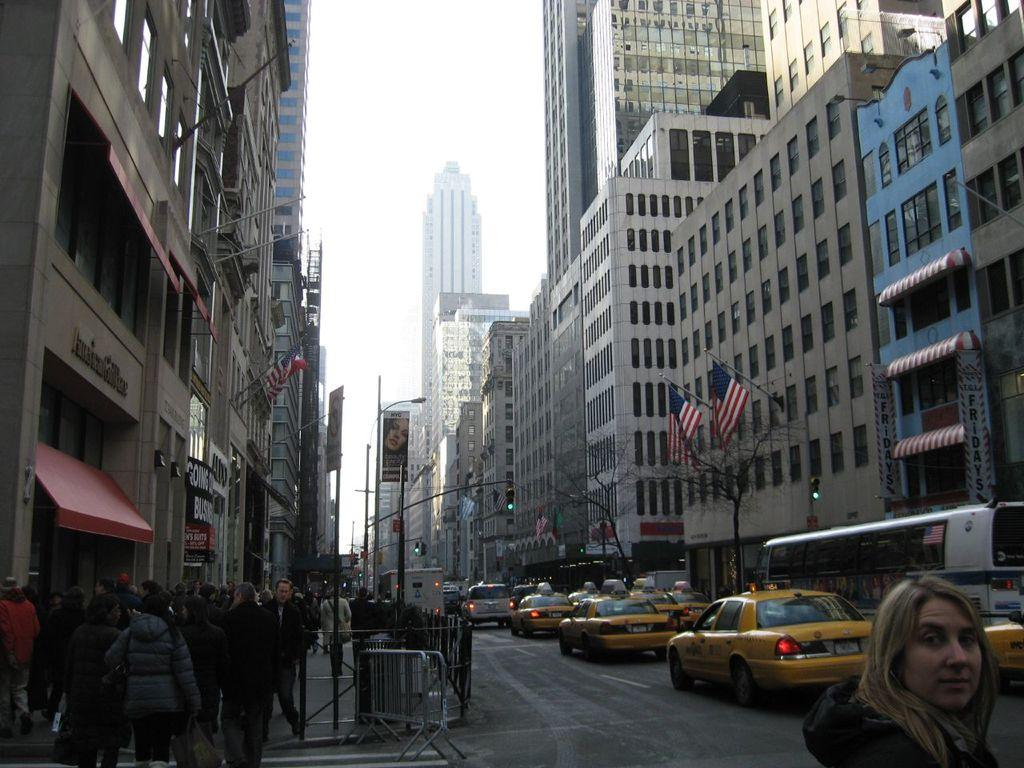<image>
Write a terse but informative summary of the picture. People walking on a street in front of an American Girl Place building. 